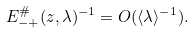Convert formula to latex. <formula><loc_0><loc_0><loc_500><loc_500>E _ { - + } ^ { \# } ( z , \lambda ) ^ { - 1 } = O ( \langle \lambda \rangle ^ { - 1 } ) .</formula> 